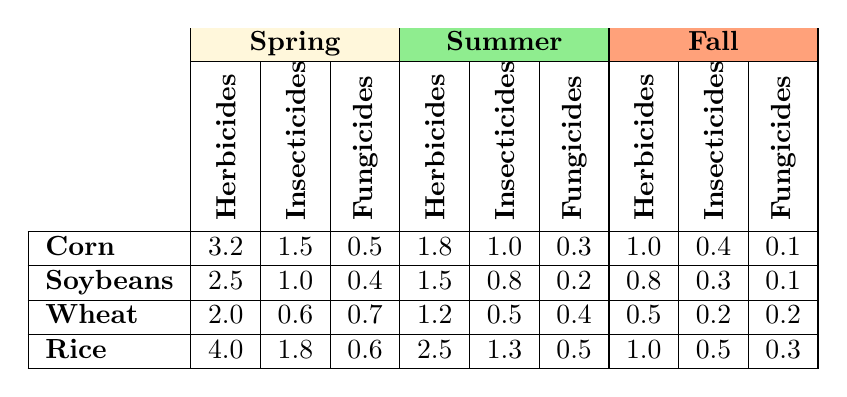What is the herbicide application rate for corn in the spring? The table lists the herbicide application rate for corn in the spring under the "Herbicides (kg/ha)" column, which shows a value of 3.2.
Answer: 3.2 Which crop has the highest insecticide application rate in the summer? To determine this, we look at the insecticide application rates in the summer for all crops: Corn (1.0), Soybeans (0.8), Wheat (0.5), and Rice (1.3). The highest value is for Rice, with 1.3.
Answer: Rice What is the total fungicide application rate for wheat across all seasons? First, we find the fungicide application rates for wheat in all seasons: Spring (0.7), Summer (0.4), Fall (0.2). We sum these values: 0.7 + 0.4 + 0.2 = 1.3.
Answer: 1.3 Is the herbicide application rate for soybeans higher in spring than in fall? The herbicide application rate for soybeans in spring is 2.5 and in fall, it is 0.8. Since 2.5 is greater than 0.8, the statement is true.
Answer: Yes What is the average insecticide application rate for corn across all seasons? We find the insecticide application rates for corn in all seasons: Spring (1.5), Summer (1.0), Fall (0.4). The average is calculated by summing these values (1.5 + 1.0 + 0.4 = 2.9) and dividing by the number of seasons (3): 2.9 / 3 = 0.967.
Answer: 0.967 Which crop has the lowest combined herbicide usage across all seasons? We calculate the total herbicide usage for each crop: Corn (3.2 + 1.8 + 1.0 = 6.0), Soybeans (2.5 + 1.5 + 0.8 = 4.8), Wheat (2.0 + 1.2 + 0.5 = 3.7), Rice (4.0 + 2.5 + 1.0 = 7.5). Wheat has the lowest total at 3.7.
Answer: Wheat In which season does rice have the highest application rate of herbicides? By inspecting the herbicide application rates for rice: Spring (4.0), Summer (2.5), Fall (1.0), it is clear that spring has the highest rate at 4.0.
Answer: Spring 